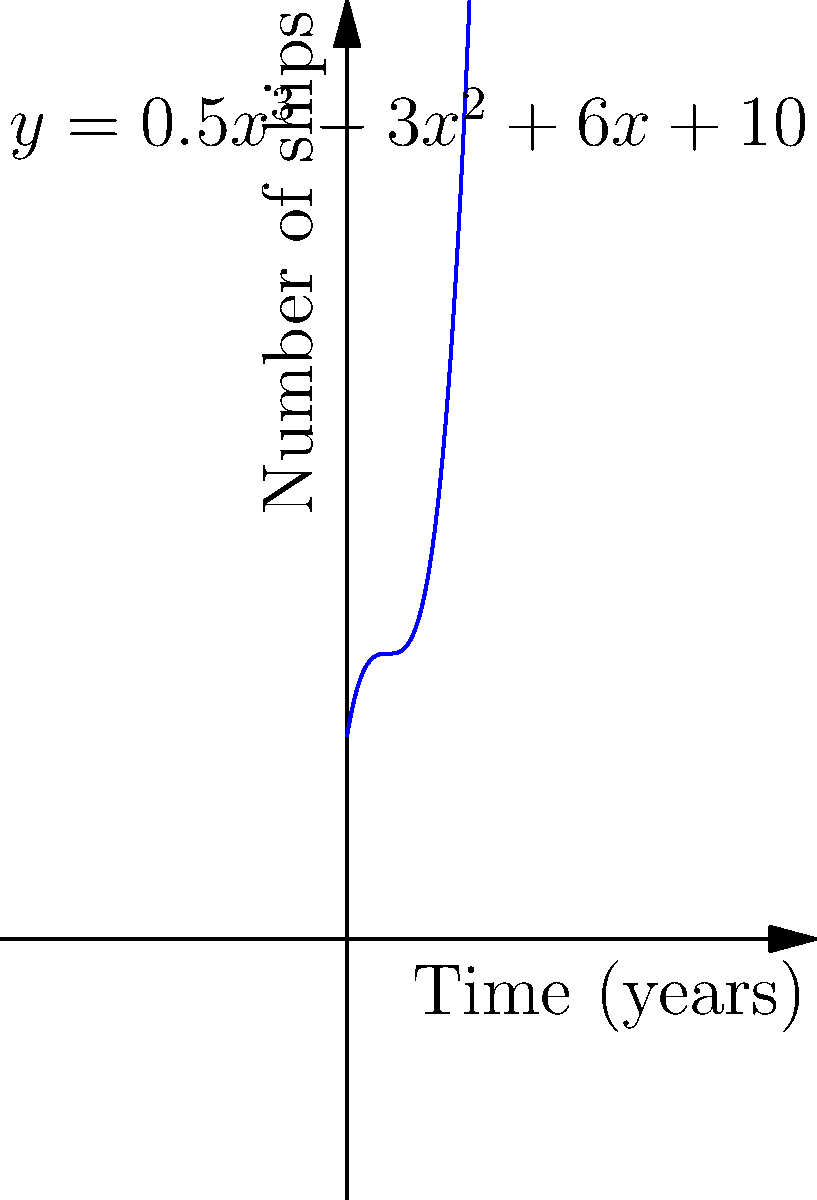Based on your insider knowledge of pirate fleet growth, the function $y = 0.5x^3 - 3x^2 + 6x + 10$ represents the number of ships in a growing pirate fleet over time, where $x$ is the number of years since the fleet's formation and $y$ is the number of ships. At what point in time will the fleet reach its minimum size, and how many ships will it have at that point? To find the minimum point of the fleet's size, we need to follow these steps:

1) First, we need to find the derivative of the function:
   $f'(x) = 1.5x^2 - 6x + 6$

2) Set the derivative equal to zero to find the critical points:
   $1.5x^2 - 6x + 6 = 0$

3) This is a quadratic equation. We can solve it using the quadratic formula:
   $x = \frac{-b \pm \sqrt{b^2 - 4ac}}{2a}$

   Where $a = 1.5$, $b = -6$, and $c = 6$

4) Plugging in these values:
   $x = \frac{6 \pm \sqrt{36 - 36}}{3} = \frac{6 \pm 0}{3} = 2$

5) The critical point occurs at $x = 2$ years.

6) To confirm this is a minimum, we can check the second derivative:
   $f''(x) = 3x - 6$
   $f''(2) = 3(2) - 6 = 0$
   Since $f''(2) = 0$, we need to check values on either side:
   $f''(1.9) < 0$ and $f''(2.1) > 0$, confirming $x = 2$ is a minimum.

7) To find the number of ships at this point, we plug $x = 2$ into the original function:
   $y = 0.5(2)^3 - 3(2)^2 + 6(2) + 10$
   $y = 4 - 12 + 12 + 10 = 14$

Therefore, the fleet will reach its minimum size of 14 ships after 2 years.
Answer: 2 years, 14 ships 